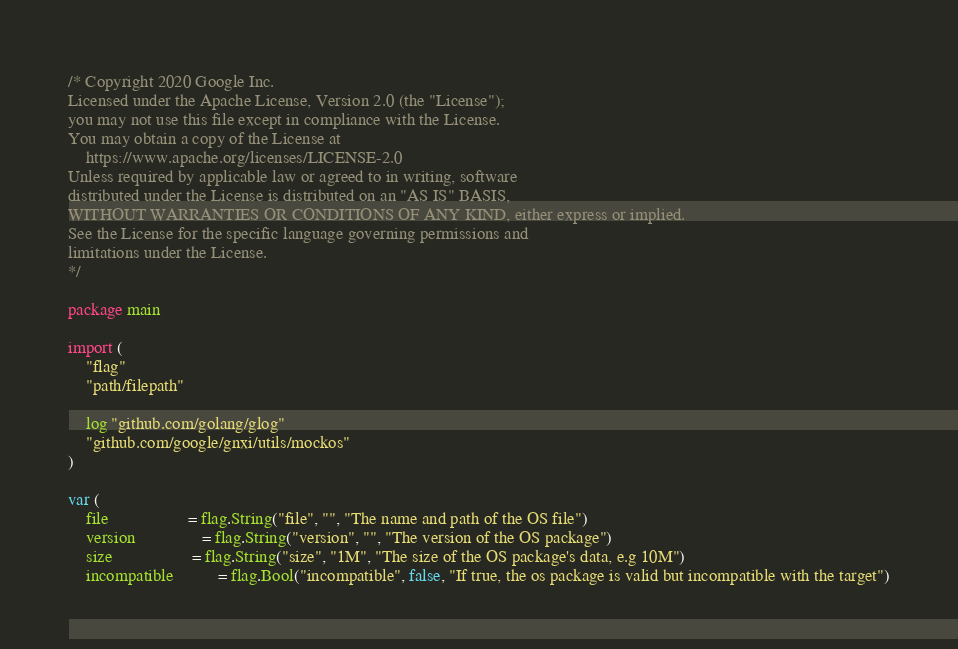Convert code to text. <code><loc_0><loc_0><loc_500><loc_500><_Go_>/* Copyright 2020 Google Inc.
Licensed under the Apache License, Version 2.0 (the "License");
you may not use this file except in compliance with the License.
You may obtain a copy of the License at
    https://www.apache.org/licenses/LICENSE-2.0
Unless required by applicable law or agreed to in writing, software
distributed under the License is distributed on an "AS IS" BASIS,
WITHOUT WARRANTIES OR CONDITIONS OF ANY KIND, either express or implied.
See the License for the specific language governing permissions and
limitations under the License.
*/

package main

import (
	"flag"
	"path/filepath"

	log "github.com/golang/glog"
	"github.com/google/gnxi/utils/mockos"
)

var (
	file                  = flag.String("file", "", "The name and path of the OS file")
	version               = flag.String("version", "", "The version of the OS package")
	size                  = flag.String("size", "1M", "The size of the OS package's data, e.g 10M")
	incompatible          = flag.Bool("incompatible", false, "If true, the os package is valid but incompatible with the target")</code> 